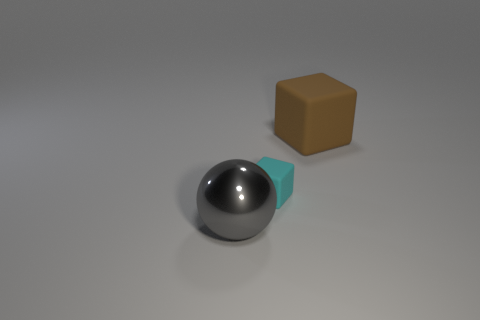What number of matte objects are large balls or large objects?
Offer a terse response. 1. There is a object that is in front of the large brown thing and behind the gray metallic thing; what material is it?
Provide a succinct answer. Rubber. Are there any brown objects that are in front of the large object that is to the right of the large object that is to the left of the big matte object?
Your answer should be compact. No. Is there anything else that has the same material as the gray thing?
Your response must be concise. No. There is a large brown object that is made of the same material as the small object; what is its shape?
Provide a short and direct response. Cube. Is the number of brown rubber cubes behind the big cube less than the number of tiny cyan objects in front of the small cyan matte object?
Keep it short and to the point. No. What number of small objects are either cyan cubes or blue metallic spheres?
Keep it short and to the point. 1. There is a large object that is on the right side of the big metal sphere; is it the same shape as the big object that is in front of the tiny matte cube?
Keep it short and to the point. No. There is a thing that is on the left side of the cube in front of the block that is behind the small matte cube; how big is it?
Offer a very short reply. Large. There is a rubber object that is behind the cyan matte block; how big is it?
Give a very brief answer. Large. 